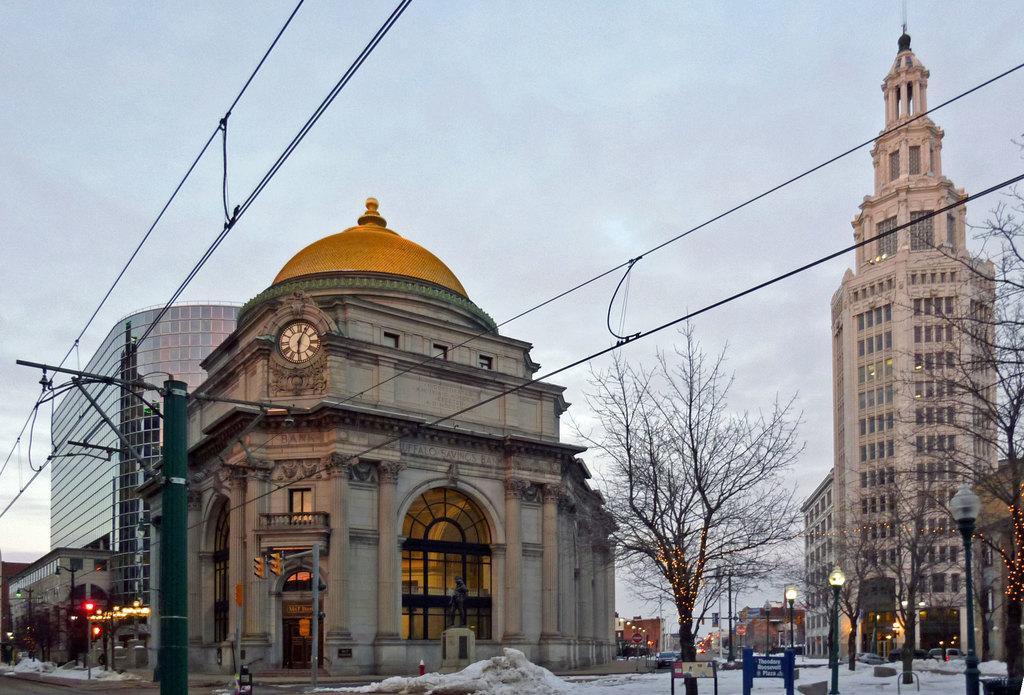Could you give a brief overview of what you see in this image? In this image we can see so many buildings, trees, poles, wires. The sky is full of clouds. The land is covered with snow. 